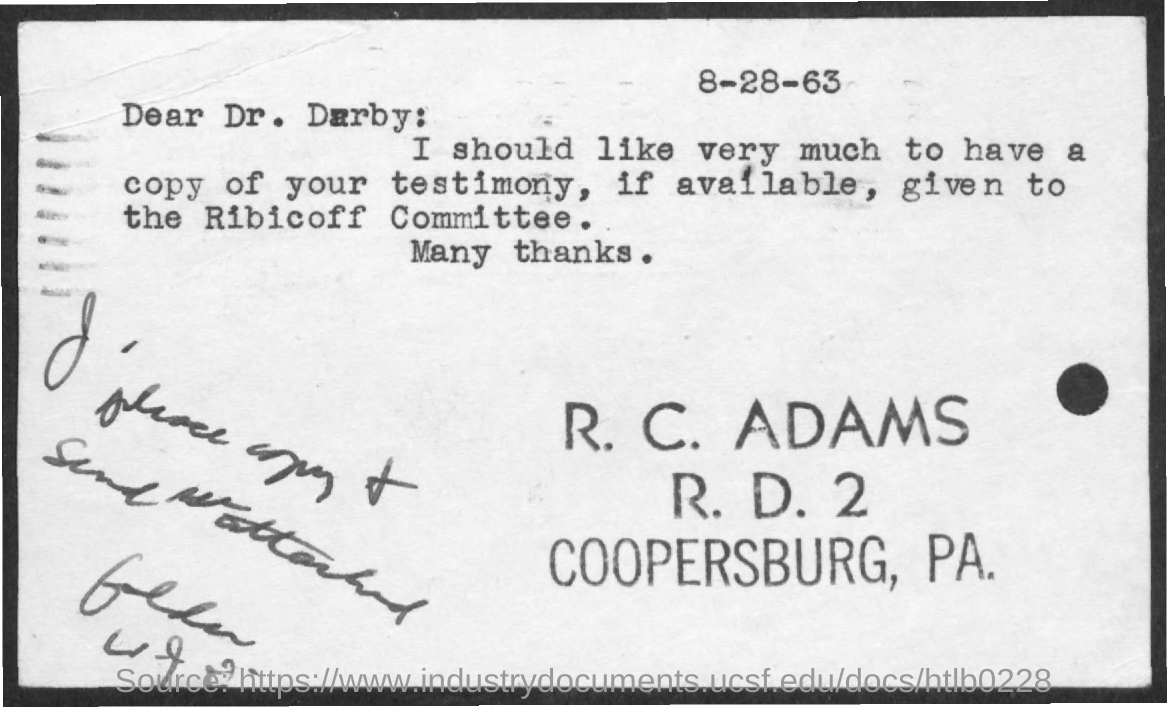What is the date mentioned?
Offer a very short reply. 8-28-63. Who is the sender of the letter?
Give a very brief answer. R. C. Adams. To whom is the letter addressed to?
Provide a succinct answer. Dr. Darby. To whom should the testimony given to?
Provide a short and direct response. Ribicoff Committee. 